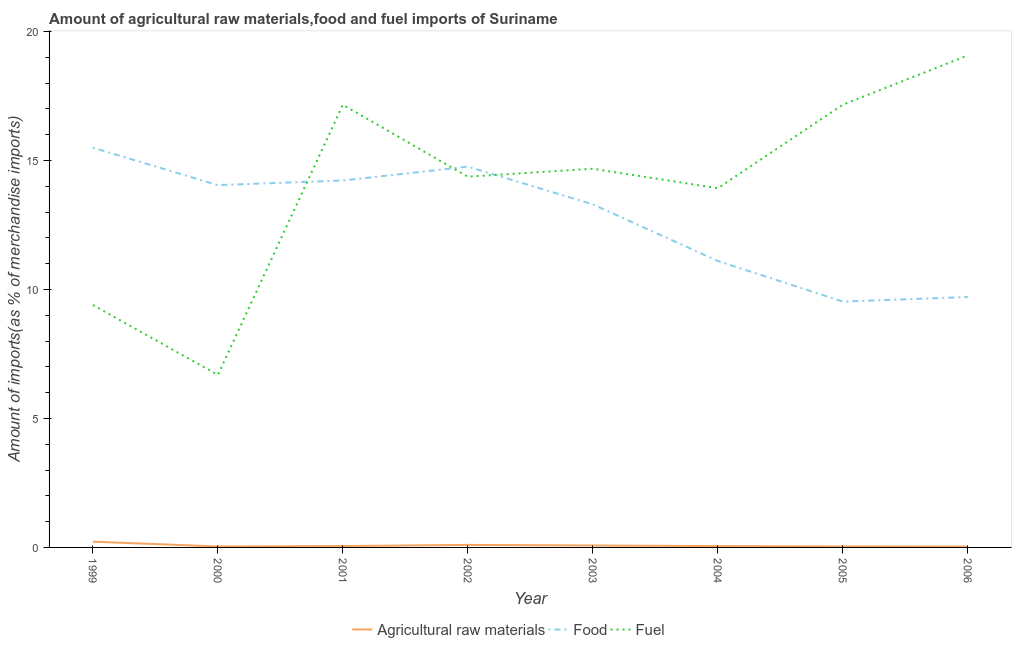Does the line corresponding to percentage of raw materials imports intersect with the line corresponding to percentage of fuel imports?
Make the answer very short. No. What is the percentage of raw materials imports in 2006?
Your answer should be compact. 0.03. Across all years, what is the maximum percentage of raw materials imports?
Provide a short and direct response. 0.22. Across all years, what is the minimum percentage of food imports?
Your response must be concise. 9.53. In which year was the percentage of fuel imports maximum?
Offer a very short reply. 2006. What is the total percentage of raw materials imports in the graph?
Keep it short and to the point. 0.61. What is the difference between the percentage of raw materials imports in 2001 and that in 2002?
Make the answer very short. -0.04. What is the difference between the percentage of food imports in 2006 and the percentage of fuel imports in 2005?
Keep it short and to the point. -7.45. What is the average percentage of fuel imports per year?
Your answer should be very brief. 14.06. In the year 2001, what is the difference between the percentage of raw materials imports and percentage of food imports?
Your answer should be very brief. -14.17. In how many years, is the percentage of raw materials imports greater than 17 %?
Keep it short and to the point. 0. What is the ratio of the percentage of fuel imports in 2002 to that in 2006?
Your answer should be compact. 0.75. Is the percentage of fuel imports in 2000 less than that in 2001?
Give a very brief answer. Yes. Is the difference between the percentage of food imports in 2004 and 2005 greater than the difference between the percentage of raw materials imports in 2004 and 2005?
Your answer should be very brief. Yes. What is the difference between the highest and the second highest percentage of raw materials imports?
Ensure brevity in your answer.  0.13. What is the difference between the highest and the lowest percentage of fuel imports?
Your answer should be compact. 12.39. Is it the case that in every year, the sum of the percentage of raw materials imports and percentage of food imports is greater than the percentage of fuel imports?
Your response must be concise. No. Does the percentage of fuel imports monotonically increase over the years?
Your response must be concise. No. Is the percentage of food imports strictly less than the percentage of fuel imports over the years?
Ensure brevity in your answer.  No. How many lines are there?
Provide a short and direct response. 3. What is the difference between two consecutive major ticks on the Y-axis?
Give a very brief answer. 5. Are the values on the major ticks of Y-axis written in scientific E-notation?
Offer a terse response. No. Does the graph contain grids?
Ensure brevity in your answer.  No. Where does the legend appear in the graph?
Ensure brevity in your answer.  Bottom center. How many legend labels are there?
Ensure brevity in your answer.  3. How are the legend labels stacked?
Your answer should be compact. Horizontal. What is the title of the graph?
Provide a succinct answer. Amount of agricultural raw materials,food and fuel imports of Suriname. Does "Maunufacturing" appear as one of the legend labels in the graph?
Keep it short and to the point. No. What is the label or title of the Y-axis?
Offer a very short reply. Amount of imports(as % of merchandise imports). What is the Amount of imports(as % of merchandise imports) of Agricultural raw materials in 1999?
Your answer should be compact. 0.22. What is the Amount of imports(as % of merchandise imports) in Food in 1999?
Your answer should be very brief. 15.49. What is the Amount of imports(as % of merchandise imports) in Fuel in 1999?
Provide a succinct answer. 9.4. What is the Amount of imports(as % of merchandise imports) of Agricultural raw materials in 2000?
Offer a terse response. 0.04. What is the Amount of imports(as % of merchandise imports) of Food in 2000?
Your answer should be very brief. 14.04. What is the Amount of imports(as % of merchandise imports) in Fuel in 2000?
Ensure brevity in your answer.  6.69. What is the Amount of imports(as % of merchandise imports) of Agricultural raw materials in 2001?
Provide a succinct answer. 0.05. What is the Amount of imports(as % of merchandise imports) of Food in 2001?
Make the answer very short. 14.22. What is the Amount of imports(as % of merchandise imports) of Fuel in 2001?
Provide a short and direct response. 17.16. What is the Amount of imports(as % of merchandise imports) of Agricultural raw materials in 2002?
Your answer should be compact. 0.1. What is the Amount of imports(as % of merchandise imports) in Food in 2002?
Provide a succinct answer. 14.76. What is the Amount of imports(as % of merchandise imports) of Fuel in 2002?
Your answer should be very brief. 14.37. What is the Amount of imports(as % of merchandise imports) of Agricultural raw materials in 2003?
Offer a terse response. 0.08. What is the Amount of imports(as % of merchandise imports) of Food in 2003?
Your answer should be very brief. 13.3. What is the Amount of imports(as % of merchandise imports) in Fuel in 2003?
Offer a terse response. 14.68. What is the Amount of imports(as % of merchandise imports) of Agricultural raw materials in 2004?
Offer a terse response. 0.05. What is the Amount of imports(as % of merchandise imports) in Food in 2004?
Offer a terse response. 11.1. What is the Amount of imports(as % of merchandise imports) of Fuel in 2004?
Your answer should be compact. 13.92. What is the Amount of imports(as % of merchandise imports) of Agricultural raw materials in 2005?
Provide a short and direct response. 0.04. What is the Amount of imports(as % of merchandise imports) in Food in 2005?
Offer a very short reply. 9.53. What is the Amount of imports(as % of merchandise imports) in Fuel in 2005?
Offer a very short reply. 17.16. What is the Amount of imports(as % of merchandise imports) of Agricultural raw materials in 2006?
Keep it short and to the point. 0.03. What is the Amount of imports(as % of merchandise imports) in Food in 2006?
Provide a succinct answer. 9.71. What is the Amount of imports(as % of merchandise imports) of Fuel in 2006?
Your answer should be compact. 19.07. Across all years, what is the maximum Amount of imports(as % of merchandise imports) in Agricultural raw materials?
Make the answer very short. 0.22. Across all years, what is the maximum Amount of imports(as % of merchandise imports) of Food?
Provide a succinct answer. 15.49. Across all years, what is the maximum Amount of imports(as % of merchandise imports) of Fuel?
Your answer should be very brief. 19.07. Across all years, what is the minimum Amount of imports(as % of merchandise imports) in Agricultural raw materials?
Ensure brevity in your answer.  0.03. Across all years, what is the minimum Amount of imports(as % of merchandise imports) of Food?
Provide a succinct answer. 9.53. Across all years, what is the minimum Amount of imports(as % of merchandise imports) of Fuel?
Provide a succinct answer. 6.69. What is the total Amount of imports(as % of merchandise imports) in Agricultural raw materials in the graph?
Provide a succinct answer. 0.61. What is the total Amount of imports(as % of merchandise imports) in Food in the graph?
Make the answer very short. 102.16. What is the total Amount of imports(as % of merchandise imports) in Fuel in the graph?
Give a very brief answer. 112.45. What is the difference between the Amount of imports(as % of merchandise imports) in Agricultural raw materials in 1999 and that in 2000?
Ensure brevity in your answer.  0.19. What is the difference between the Amount of imports(as % of merchandise imports) of Food in 1999 and that in 2000?
Ensure brevity in your answer.  1.45. What is the difference between the Amount of imports(as % of merchandise imports) of Fuel in 1999 and that in 2000?
Ensure brevity in your answer.  2.71. What is the difference between the Amount of imports(as % of merchandise imports) of Agricultural raw materials in 1999 and that in 2001?
Provide a short and direct response. 0.17. What is the difference between the Amount of imports(as % of merchandise imports) in Food in 1999 and that in 2001?
Provide a succinct answer. 1.27. What is the difference between the Amount of imports(as % of merchandise imports) in Fuel in 1999 and that in 2001?
Provide a succinct answer. -7.76. What is the difference between the Amount of imports(as % of merchandise imports) in Agricultural raw materials in 1999 and that in 2002?
Offer a very short reply. 0.13. What is the difference between the Amount of imports(as % of merchandise imports) in Food in 1999 and that in 2002?
Offer a terse response. 0.73. What is the difference between the Amount of imports(as % of merchandise imports) of Fuel in 1999 and that in 2002?
Provide a short and direct response. -4.97. What is the difference between the Amount of imports(as % of merchandise imports) in Agricultural raw materials in 1999 and that in 2003?
Your answer should be compact. 0.15. What is the difference between the Amount of imports(as % of merchandise imports) of Food in 1999 and that in 2003?
Give a very brief answer. 2.2. What is the difference between the Amount of imports(as % of merchandise imports) in Fuel in 1999 and that in 2003?
Your answer should be compact. -5.28. What is the difference between the Amount of imports(as % of merchandise imports) in Agricultural raw materials in 1999 and that in 2004?
Offer a terse response. 0.17. What is the difference between the Amount of imports(as % of merchandise imports) of Food in 1999 and that in 2004?
Your response must be concise. 4.39. What is the difference between the Amount of imports(as % of merchandise imports) of Fuel in 1999 and that in 2004?
Your answer should be compact. -4.53. What is the difference between the Amount of imports(as % of merchandise imports) in Agricultural raw materials in 1999 and that in 2005?
Your response must be concise. 0.18. What is the difference between the Amount of imports(as % of merchandise imports) of Food in 1999 and that in 2005?
Offer a terse response. 5.96. What is the difference between the Amount of imports(as % of merchandise imports) in Fuel in 1999 and that in 2005?
Provide a succinct answer. -7.76. What is the difference between the Amount of imports(as % of merchandise imports) in Agricultural raw materials in 1999 and that in 2006?
Ensure brevity in your answer.  0.19. What is the difference between the Amount of imports(as % of merchandise imports) of Food in 1999 and that in 2006?
Offer a very short reply. 5.79. What is the difference between the Amount of imports(as % of merchandise imports) in Fuel in 1999 and that in 2006?
Your answer should be very brief. -9.68. What is the difference between the Amount of imports(as % of merchandise imports) in Agricultural raw materials in 2000 and that in 2001?
Provide a succinct answer. -0.02. What is the difference between the Amount of imports(as % of merchandise imports) of Food in 2000 and that in 2001?
Provide a succinct answer. -0.18. What is the difference between the Amount of imports(as % of merchandise imports) in Fuel in 2000 and that in 2001?
Your answer should be very brief. -10.47. What is the difference between the Amount of imports(as % of merchandise imports) of Agricultural raw materials in 2000 and that in 2002?
Provide a short and direct response. -0.06. What is the difference between the Amount of imports(as % of merchandise imports) in Food in 2000 and that in 2002?
Your response must be concise. -0.72. What is the difference between the Amount of imports(as % of merchandise imports) of Fuel in 2000 and that in 2002?
Make the answer very short. -7.68. What is the difference between the Amount of imports(as % of merchandise imports) in Agricultural raw materials in 2000 and that in 2003?
Keep it short and to the point. -0.04. What is the difference between the Amount of imports(as % of merchandise imports) of Food in 2000 and that in 2003?
Keep it short and to the point. 0.75. What is the difference between the Amount of imports(as % of merchandise imports) in Fuel in 2000 and that in 2003?
Keep it short and to the point. -7.99. What is the difference between the Amount of imports(as % of merchandise imports) in Agricultural raw materials in 2000 and that in 2004?
Your response must be concise. -0.01. What is the difference between the Amount of imports(as % of merchandise imports) in Food in 2000 and that in 2004?
Make the answer very short. 2.94. What is the difference between the Amount of imports(as % of merchandise imports) of Fuel in 2000 and that in 2004?
Offer a terse response. -7.24. What is the difference between the Amount of imports(as % of merchandise imports) in Agricultural raw materials in 2000 and that in 2005?
Provide a succinct answer. -0. What is the difference between the Amount of imports(as % of merchandise imports) of Food in 2000 and that in 2005?
Offer a terse response. 4.51. What is the difference between the Amount of imports(as % of merchandise imports) of Fuel in 2000 and that in 2005?
Offer a terse response. -10.47. What is the difference between the Amount of imports(as % of merchandise imports) in Agricultural raw materials in 2000 and that in 2006?
Offer a terse response. 0. What is the difference between the Amount of imports(as % of merchandise imports) in Food in 2000 and that in 2006?
Your response must be concise. 4.34. What is the difference between the Amount of imports(as % of merchandise imports) of Fuel in 2000 and that in 2006?
Your answer should be compact. -12.39. What is the difference between the Amount of imports(as % of merchandise imports) of Agricultural raw materials in 2001 and that in 2002?
Offer a very short reply. -0.04. What is the difference between the Amount of imports(as % of merchandise imports) in Food in 2001 and that in 2002?
Ensure brevity in your answer.  -0.54. What is the difference between the Amount of imports(as % of merchandise imports) of Fuel in 2001 and that in 2002?
Provide a succinct answer. 2.79. What is the difference between the Amount of imports(as % of merchandise imports) in Agricultural raw materials in 2001 and that in 2003?
Provide a short and direct response. -0.02. What is the difference between the Amount of imports(as % of merchandise imports) of Food in 2001 and that in 2003?
Keep it short and to the point. 0.93. What is the difference between the Amount of imports(as % of merchandise imports) in Fuel in 2001 and that in 2003?
Provide a succinct answer. 2.48. What is the difference between the Amount of imports(as % of merchandise imports) of Agricultural raw materials in 2001 and that in 2004?
Provide a succinct answer. 0. What is the difference between the Amount of imports(as % of merchandise imports) in Food in 2001 and that in 2004?
Make the answer very short. 3.12. What is the difference between the Amount of imports(as % of merchandise imports) of Fuel in 2001 and that in 2004?
Give a very brief answer. 3.24. What is the difference between the Amount of imports(as % of merchandise imports) of Agricultural raw materials in 2001 and that in 2005?
Your answer should be very brief. 0.01. What is the difference between the Amount of imports(as % of merchandise imports) in Food in 2001 and that in 2005?
Your answer should be very brief. 4.69. What is the difference between the Amount of imports(as % of merchandise imports) of Fuel in 2001 and that in 2005?
Give a very brief answer. -0. What is the difference between the Amount of imports(as % of merchandise imports) in Agricultural raw materials in 2001 and that in 2006?
Your answer should be compact. 0.02. What is the difference between the Amount of imports(as % of merchandise imports) of Food in 2001 and that in 2006?
Offer a terse response. 4.52. What is the difference between the Amount of imports(as % of merchandise imports) in Fuel in 2001 and that in 2006?
Your answer should be very brief. -1.91. What is the difference between the Amount of imports(as % of merchandise imports) of Agricultural raw materials in 2002 and that in 2003?
Make the answer very short. 0.02. What is the difference between the Amount of imports(as % of merchandise imports) of Food in 2002 and that in 2003?
Give a very brief answer. 1.46. What is the difference between the Amount of imports(as % of merchandise imports) of Fuel in 2002 and that in 2003?
Make the answer very short. -0.31. What is the difference between the Amount of imports(as % of merchandise imports) of Agricultural raw materials in 2002 and that in 2004?
Your answer should be compact. 0.05. What is the difference between the Amount of imports(as % of merchandise imports) of Food in 2002 and that in 2004?
Provide a succinct answer. 3.66. What is the difference between the Amount of imports(as % of merchandise imports) of Fuel in 2002 and that in 2004?
Keep it short and to the point. 0.45. What is the difference between the Amount of imports(as % of merchandise imports) of Agricultural raw materials in 2002 and that in 2005?
Provide a succinct answer. 0.06. What is the difference between the Amount of imports(as % of merchandise imports) of Food in 2002 and that in 2005?
Your answer should be very brief. 5.23. What is the difference between the Amount of imports(as % of merchandise imports) in Fuel in 2002 and that in 2005?
Offer a terse response. -2.79. What is the difference between the Amount of imports(as % of merchandise imports) of Agricultural raw materials in 2002 and that in 2006?
Your answer should be very brief. 0.06. What is the difference between the Amount of imports(as % of merchandise imports) in Food in 2002 and that in 2006?
Your response must be concise. 5.05. What is the difference between the Amount of imports(as % of merchandise imports) of Fuel in 2002 and that in 2006?
Keep it short and to the point. -4.7. What is the difference between the Amount of imports(as % of merchandise imports) of Agricultural raw materials in 2003 and that in 2004?
Provide a succinct answer. 0.02. What is the difference between the Amount of imports(as % of merchandise imports) of Food in 2003 and that in 2004?
Your answer should be compact. 2.19. What is the difference between the Amount of imports(as % of merchandise imports) in Fuel in 2003 and that in 2004?
Offer a terse response. 0.76. What is the difference between the Amount of imports(as % of merchandise imports) in Agricultural raw materials in 2003 and that in 2005?
Your response must be concise. 0.04. What is the difference between the Amount of imports(as % of merchandise imports) in Food in 2003 and that in 2005?
Provide a succinct answer. 3.77. What is the difference between the Amount of imports(as % of merchandise imports) in Fuel in 2003 and that in 2005?
Provide a succinct answer. -2.48. What is the difference between the Amount of imports(as % of merchandise imports) in Agricultural raw materials in 2003 and that in 2006?
Your answer should be compact. 0.04. What is the difference between the Amount of imports(as % of merchandise imports) in Food in 2003 and that in 2006?
Offer a terse response. 3.59. What is the difference between the Amount of imports(as % of merchandise imports) in Fuel in 2003 and that in 2006?
Make the answer very short. -4.39. What is the difference between the Amount of imports(as % of merchandise imports) of Agricultural raw materials in 2004 and that in 2005?
Make the answer very short. 0.01. What is the difference between the Amount of imports(as % of merchandise imports) of Food in 2004 and that in 2005?
Make the answer very short. 1.57. What is the difference between the Amount of imports(as % of merchandise imports) in Fuel in 2004 and that in 2005?
Your answer should be very brief. -3.24. What is the difference between the Amount of imports(as % of merchandise imports) in Agricultural raw materials in 2004 and that in 2006?
Ensure brevity in your answer.  0.02. What is the difference between the Amount of imports(as % of merchandise imports) of Food in 2004 and that in 2006?
Your response must be concise. 1.4. What is the difference between the Amount of imports(as % of merchandise imports) of Fuel in 2004 and that in 2006?
Offer a very short reply. -5.15. What is the difference between the Amount of imports(as % of merchandise imports) of Agricultural raw materials in 2005 and that in 2006?
Make the answer very short. 0.01. What is the difference between the Amount of imports(as % of merchandise imports) of Food in 2005 and that in 2006?
Keep it short and to the point. -0.18. What is the difference between the Amount of imports(as % of merchandise imports) in Fuel in 2005 and that in 2006?
Offer a very short reply. -1.91. What is the difference between the Amount of imports(as % of merchandise imports) in Agricultural raw materials in 1999 and the Amount of imports(as % of merchandise imports) in Food in 2000?
Give a very brief answer. -13.82. What is the difference between the Amount of imports(as % of merchandise imports) of Agricultural raw materials in 1999 and the Amount of imports(as % of merchandise imports) of Fuel in 2000?
Provide a short and direct response. -6.46. What is the difference between the Amount of imports(as % of merchandise imports) in Food in 1999 and the Amount of imports(as % of merchandise imports) in Fuel in 2000?
Your answer should be very brief. 8.81. What is the difference between the Amount of imports(as % of merchandise imports) of Agricultural raw materials in 1999 and the Amount of imports(as % of merchandise imports) of Food in 2001?
Provide a succinct answer. -14. What is the difference between the Amount of imports(as % of merchandise imports) in Agricultural raw materials in 1999 and the Amount of imports(as % of merchandise imports) in Fuel in 2001?
Your answer should be very brief. -16.94. What is the difference between the Amount of imports(as % of merchandise imports) in Food in 1999 and the Amount of imports(as % of merchandise imports) in Fuel in 2001?
Ensure brevity in your answer.  -1.67. What is the difference between the Amount of imports(as % of merchandise imports) in Agricultural raw materials in 1999 and the Amount of imports(as % of merchandise imports) in Food in 2002?
Ensure brevity in your answer.  -14.54. What is the difference between the Amount of imports(as % of merchandise imports) of Agricultural raw materials in 1999 and the Amount of imports(as % of merchandise imports) of Fuel in 2002?
Provide a short and direct response. -14.15. What is the difference between the Amount of imports(as % of merchandise imports) of Food in 1999 and the Amount of imports(as % of merchandise imports) of Fuel in 2002?
Offer a terse response. 1.12. What is the difference between the Amount of imports(as % of merchandise imports) of Agricultural raw materials in 1999 and the Amount of imports(as % of merchandise imports) of Food in 2003?
Make the answer very short. -13.08. What is the difference between the Amount of imports(as % of merchandise imports) of Agricultural raw materials in 1999 and the Amount of imports(as % of merchandise imports) of Fuel in 2003?
Make the answer very short. -14.46. What is the difference between the Amount of imports(as % of merchandise imports) in Food in 1999 and the Amount of imports(as % of merchandise imports) in Fuel in 2003?
Keep it short and to the point. 0.81. What is the difference between the Amount of imports(as % of merchandise imports) in Agricultural raw materials in 1999 and the Amount of imports(as % of merchandise imports) in Food in 2004?
Provide a short and direct response. -10.88. What is the difference between the Amount of imports(as % of merchandise imports) in Agricultural raw materials in 1999 and the Amount of imports(as % of merchandise imports) in Fuel in 2004?
Provide a short and direct response. -13.7. What is the difference between the Amount of imports(as % of merchandise imports) of Food in 1999 and the Amount of imports(as % of merchandise imports) of Fuel in 2004?
Offer a very short reply. 1.57. What is the difference between the Amount of imports(as % of merchandise imports) of Agricultural raw materials in 1999 and the Amount of imports(as % of merchandise imports) of Food in 2005?
Give a very brief answer. -9.31. What is the difference between the Amount of imports(as % of merchandise imports) of Agricultural raw materials in 1999 and the Amount of imports(as % of merchandise imports) of Fuel in 2005?
Your answer should be compact. -16.94. What is the difference between the Amount of imports(as % of merchandise imports) of Food in 1999 and the Amount of imports(as % of merchandise imports) of Fuel in 2005?
Your response must be concise. -1.67. What is the difference between the Amount of imports(as % of merchandise imports) of Agricultural raw materials in 1999 and the Amount of imports(as % of merchandise imports) of Food in 2006?
Your answer should be very brief. -9.48. What is the difference between the Amount of imports(as % of merchandise imports) in Agricultural raw materials in 1999 and the Amount of imports(as % of merchandise imports) in Fuel in 2006?
Your response must be concise. -18.85. What is the difference between the Amount of imports(as % of merchandise imports) of Food in 1999 and the Amount of imports(as % of merchandise imports) of Fuel in 2006?
Provide a short and direct response. -3.58. What is the difference between the Amount of imports(as % of merchandise imports) of Agricultural raw materials in 2000 and the Amount of imports(as % of merchandise imports) of Food in 2001?
Ensure brevity in your answer.  -14.19. What is the difference between the Amount of imports(as % of merchandise imports) in Agricultural raw materials in 2000 and the Amount of imports(as % of merchandise imports) in Fuel in 2001?
Make the answer very short. -17.12. What is the difference between the Amount of imports(as % of merchandise imports) of Food in 2000 and the Amount of imports(as % of merchandise imports) of Fuel in 2001?
Your answer should be compact. -3.12. What is the difference between the Amount of imports(as % of merchandise imports) in Agricultural raw materials in 2000 and the Amount of imports(as % of merchandise imports) in Food in 2002?
Your answer should be compact. -14.72. What is the difference between the Amount of imports(as % of merchandise imports) in Agricultural raw materials in 2000 and the Amount of imports(as % of merchandise imports) in Fuel in 2002?
Make the answer very short. -14.33. What is the difference between the Amount of imports(as % of merchandise imports) in Food in 2000 and the Amount of imports(as % of merchandise imports) in Fuel in 2002?
Provide a short and direct response. -0.33. What is the difference between the Amount of imports(as % of merchandise imports) in Agricultural raw materials in 2000 and the Amount of imports(as % of merchandise imports) in Food in 2003?
Offer a very short reply. -13.26. What is the difference between the Amount of imports(as % of merchandise imports) in Agricultural raw materials in 2000 and the Amount of imports(as % of merchandise imports) in Fuel in 2003?
Your response must be concise. -14.64. What is the difference between the Amount of imports(as % of merchandise imports) in Food in 2000 and the Amount of imports(as % of merchandise imports) in Fuel in 2003?
Offer a terse response. -0.64. What is the difference between the Amount of imports(as % of merchandise imports) of Agricultural raw materials in 2000 and the Amount of imports(as % of merchandise imports) of Food in 2004?
Your response must be concise. -11.07. What is the difference between the Amount of imports(as % of merchandise imports) in Agricultural raw materials in 2000 and the Amount of imports(as % of merchandise imports) in Fuel in 2004?
Your response must be concise. -13.89. What is the difference between the Amount of imports(as % of merchandise imports) of Food in 2000 and the Amount of imports(as % of merchandise imports) of Fuel in 2004?
Your response must be concise. 0.12. What is the difference between the Amount of imports(as % of merchandise imports) of Agricultural raw materials in 2000 and the Amount of imports(as % of merchandise imports) of Food in 2005?
Your answer should be very brief. -9.49. What is the difference between the Amount of imports(as % of merchandise imports) of Agricultural raw materials in 2000 and the Amount of imports(as % of merchandise imports) of Fuel in 2005?
Make the answer very short. -17.12. What is the difference between the Amount of imports(as % of merchandise imports) in Food in 2000 and the Amount of imports(as % of merchandise imports) in Fuel in 2005?
Provide a short and direct response. -3.12. What is the difference between the Amount of imports(as % of merchandise imports) of Agricultural raw materials in 2000 and the Amount of imports(as % of merchandise imports) of Food in 2006?
Your answer should be compact. -9.67. What is the difference between the Amount of imports(as % of merchandise imports) of Agricultural raw materials in 2000 and the Amount of imports(as % of merchandise imports) of Fuel in 2006?
Ensure brevity in your answer.  -19.04. What is the difference between the Amount of imports(as % of merchandise imports) of Food in 2000 and the Amount of imports(as % of merchandise imports) of Fuel in 2006?
Provide a short and direct response. -5.03. What is the difference between the Amount of imports(as % of merchandise imports) of Agricultural raw materials in 2001 and the Amount of imports(as % of merchandise imports) of Food in 2002?
Ensure brevity in your answer.  -14.71. What is the difference between the Amount of imports(as % of merchandise imports) in Agricultural raw materials in 2001 and the Amount of imports(as % of merchandise imports) in Fuel in 2002?
Keep it short and to the point. -14.32. What is the difference between the Amount of imports(as % of merchandise imports) in Food in 2001 and the Amount of imports(as % of merchandise imports) in Fuel in 2002?
Offer a terse response. -0.15. What is the difference between the Amount of imports(as % of merchandise imports) of Agricultural raw materials in 2001 and the Amount of imports(as % of merchandise imports) of Food in 2003?
Provide a short and direct response. -13.24. What is the difference between the Amount of imports(as % of merchandise imports) in Agricultural raw materials in 2001 and the Amount of imports(as % of merchandise imports) in Fuel in 2003?
Provide a short and direct response. -14.63. What is the difference between the Amount of imports(as % of merchandise imports) in Food in 2001 and the Amount of imports(as % of merchandise imports) in Fuel in 2003?
Provide a succinct answer. -0.46. What is the difference between the Amount of imports(as % of merchandise imports) of Agricultural raw materials in 2001 and the Amount of imports(as % of merchandise imports) of Food in 2004?
Give a very brief answer. -11.05. What is the difference between the Amount of imports(as % of merchandise imports) of Agricultural raw materials in 2001 and the Amount of imports(as % of merchandise imports) of Fuel in 2004?
Your response must be concise. -13.87. What is the difference between the Amount of imports(as % of merchandise imports) in Food in 2001 and the Amount of imports(as % of merchandise imports) in Fuel in 2004?
Your answer should be compact. 0.3. What is the difference between the Amount of imports(as % of merchandise imports) of Agricultural raw materials in 2001 and the Amount of imports(as % of merchandise imports) of Food in 2005?
Offer a very short reply. -9.48. What is the difference between the Amount of imports(as % of merchandise imports) in Agricultural raw materials in 2001 and the Amount of imports(as % of merchandise imports) in Fuel in 2005?
Your answer should be compact. -17.11. What is the difference between the Amount of imports(as % of merchandise imports) in Food in 2001 and the Amount of imports(as % of merchandise imports) in Fuel in 2005?
Your answer should be compact. -2.94. What is the difference between the Amount of imports(as % of merchandise imports) in Agricultural raw materials in 2001 and the Amount of imports(as % of merchandise imports) in Food in 2006?
Provide a short and direct response. -9.65. What is the difference between the Amount of imports(as % of merchandise imports) in Agricultural raw materials in 2001 and the Amount of imports(as % of merchandise imports) in Fuel in 2006?
Your response must be concise. -19.02. What is the difference between the Amount of imports(as % of merchandise imports) in Food in 2001 and the Amount of imports(as % of merchandise imports) in Fuel in 2006?
Ensure brevity in your answer.  -4.85. What is the difference between the Amount of imports(as % of merchandise imports) of Agricultural raw materials in 2002 and the Amount of imports(as % of merchandise imports) of Food in 2003?
Give a very brief answer. -13.2. What is the difference between the Amount of imports(as % of merchandise imports) of Agricultural raw materials in 2002 and the Amount of imports(as % of merchandise imports) of Fuel in 2003?
Keep it short and to the point. -14.58. What is the difference between the Amount of imports(as % of merchandise imports) in Food in 2002 and the Amount of imports(as % of merchandise imports) in Fuel in 2003?
Ensure brevity in your answer.  0.08. What is the difference between the Amount of imports(as % of merchandise imports) in Agricultural raw materials in 2002 and the Amount of imports(as % of merchandise imports) in Food in 2004?
Offer a very short reply. -11.01. What is the difference between the Amount of imports(as % of merchandise imports) of Agricultural raw materials in 2002 and the Amount of imports(as % of merchandise imports) of Fuel in 2004?
Offer a very short reply. -13.83. What is the difference between the Amount of imports(as % of merchandise imports) in Food in 2002 and the Amount of imports(as % of merchandise imports) in Fuel in 2004?
Make the answer very short. 0.84. What is the difference between the Amount of imports(as % of merchandise imports) in Agricultural raw materials in 2002 and the Amount of imports(as % of merchandise imports) in Food in 2005?
Offer a very short reply. -9.43. What is the difference between the Amount of imports(as % of merchandise imports) of Agricultural raw materials in 2002 and the Amount of imports(as % of merchandise imports) of Fuel in 2005?
Ensure brevity in your answer.  -17.06. What is the difference between the Amount of imports(as % of merchandise imports) in Food in 2002 and the Amount of imports(as % of merchandise imports) in Fuel in 2005?
Make the answer very short. -2.4. What is the difference between the Amount of imports(as % of merchandise imports) of Agricultural raw materials in 2002 and the Amount of imports(as % of merchandise imports) of Food in 2006?
Make the answer very short. -9.61. What is the difference between the Amount of imports(as % of merchandise imports) of Agricultural raw materials in 2002 and the Amount of imports(as % of merchandise imports) of Fuel in 2006?
Offer a very short reply. -18.98. What is the difference between the Amount of imports(as % of merchandise imports) of Food in 2002 and the Amount of imports(as % of merchandise imports) of Fuel in 2006?
Offer a very short reply. -4.31. What is the difference between the Amount of imports(as % of merchandise imports) of Agricultural raw materials in 2003 and the Amount of imports(as % of merchandise imports) of Food in 2004?
Make the answer very short. -11.03. What is the difference between the Amount of imports(as % of merchandise imports) in Agricultural raw materials in 2003 and the Amount of imports(as % of merchandise imports) in Fuel in 2004?
Your answer should be compact. -13.85. What is the difference between the Amount of imports(as % of merchandise imports) of Food in 2003 and the Amount of imports(as % of merchandise imports) of Fuel in 2004?
Give a very brief answer. -0.63. What is the difference between the Amount of imports(as % of merchandise imports) in Agricultural raw materials in 2003 and the Amount of imports(as % of merchandise imports) in Food in 2005?
Ensure brevity in your answer.  -9.45. What is the difference between the Amount of imports(as % of merchandise imports) of Agricultural raw materials in 2003 and the Amount of imports(as % of merchandise imports) of Fuel in 2005?
Keep it short and to the point. -17.09. What is the difference between the Amount of imports(as % of merchandise imports) in Food in 2003 and the Amount of imports(as % of merchandise imports) in Fuel in 2005?
Provide a succinct answer. -3.86. What is the difference between the Amount of imports(as % of merchandise imports) of Agricultural raw materials in 2003 and the Amount of imports(as % of merchandise imports) of Food in 2006?
Offer a terse response. -9.63. What is the difference between the Amount of imports(as % of merchandise imports) of Agricultural raw materials in 2003 and the Amount of imports(as % of merchandise imports) of Fuel in 2006?
Provide a short and direct response. -19. What is the difference between the Amount of imports(as % of merchandise imports) in Food in 2003 and the Amount of imports(as % of merchandise imports) in Fuel in 2006?
Provide a succinct answer. -5.78. What is the difference between the Amount of imports(as % of merchandise imports) in Agricultural raw materials in 2004 and the Amount of imports(as % of merchandise imports) in Food in 2005?
Offer a terse response. -9.48. What is the difference between the Amount of imports(as % of merchandise imports) of Agricultural raw materials in 2004 and the Amount of imports(as % of merchandise imports) of Fuel in 2005?
Give a very brief answer. -17.11. What is the difference between the Amount of imports(as % of merchandise imports) in Food in 2004 and the Amount of imports(as % of merchandise imports) in Fuel in 2005?
Your answer should be very brief. -6.06. What is the difference between the Amount of imports(as % of merchandise imports) in Agricultural raw materials in 2004 and the Amount of imports(as % of merchandise imports) in Food in 2006?
Offer a very short reply. -9.66. What is the difference between the Amount of imports(as % of merchandise imports) in Agricultural raw materials in 2004 and the Amount of imports(as % of merchandise imports) in Fuel in 2006?
Provide a succinct answer. -19.02. What is the difference between the Amount of imports(as % of merchandise imports) in Food in 2004 and the Amount of imports(as % of merchandise imports) in Fuel in 2006?
Offer a terse response. -7.97. What is the difference between the Amount of imports(as % of merchandise imports) of Agricultural raw materials in 2005 and the Amount of imports(as % of merchandise imports) of Food in 2006?
Your answer should be compact. -9.67. What is the difference between the Amount of imports(as % of merchandise imports) of Agricultural raw materials in 2005 and the Amount of imports(as % of merchandise imports) of Fuel in 2006?
Ensure brevity in your answer.  -19.03. What is the difference between the Amount of imports(as % of merchandise imports) in Food in 2005 and the Amount of imports(as % of merchandise imports) in Fuel in 2006?
Your response must be concise. -9.54. What is the average Amount of imports(as % of merchandise imports) in Agricultural raw materials per year?
Provide a succinct answer. 0.08. What is the average Amount of imports(as % of merchandise imports) in Food per year?
Your response must be concise. 12.77. What is the average Amount of imports(as % of merchandise imports) in Fuel per year?
Provide a succinct answer. 14.06. In the year 1999, what is the difference between the Amount of imports(as % of merchandise imports) of Agricultural raw materials and Amount of imports(as % of merchandise imports) of Food?
Your response must be concise. -15.27. In the year 1999, what is the difference between the Amount of imports(as % of merchandise imports) of Agricultural raw materials and Amount of imports(as % of merchandise imports) of Fuel?
Make the answer very short. -9.17. In the year 1999, what is the difference between the Amount of imports(as % of merchandise imports) of Food and Amount of imports(as % of merchandise imports) of Fuel?
Ensure brevity in your answer.  6.1. In the year 2000, what is the difference between the Amount of imports(as % of merchandise imports) of Agricultural raw materials and Amount of imports(as % of merchandise imports) of Food?
Offer a terse response. -14.01. In the year 2000, what is the difference between the Amount of imports(as % of merchandise imports) in Agricultural raw materials and Amount of imports(as % of merchandise imports) in Fuel?
Keep it short and to the point. -6.65. In the year 2000, what is the difference between the Amount of imports(as % of merchandise imports) of Food and Amount of imports(as % of merchandise imports) of Fuel?
Your answer should be compact. 7.36. In the year 2001, what is the difference between the Amount of imports(as % of merchandise imports) in Agricultural raw materials and Amount of imports(as % of merchandise imports) in Food?
Your response must be concise. -14.17. In the year 2001, what is the difference between the Amount of imports(as % of merchandise imports) in Agricultural raw materials and Amount of imports(as % of merchandise imports) in Fuel?
Offer a very short reply. -17.11. In the year 2001, what is the difference between the Amount of imports(as % of merchandise imports) of Food and Amount of imports(as % of merchandise imports) of Fuel?
Offer a terse response. -2.94. In the year 2002, what is the difference between the Amount of imports(as % of merchandise imports) of Agricultural raw materials and Amount of imports(as % of merchandise imports) of Food?
Your answer should be very brief. -14.66. In the year 2002, what is the difference between the Amount of imports(as % of merchandise imports) of Agricultural raw materials and Amount of imports(as % of merchandise imports) of Fuel?
Provide a short and direct response. -14.27. In the year 2002, what is the difference between the Amount of imports(as % of merchandise imports) of Food and Amount of imports(as % of merchandise imports) of Fuel?
Make the answer very short. 0.39. In the year 2003, what is the difference between the Amount of imports(as % of merchandise imports) in Agricultural raw materials and Amount of imports(as % of merchandise imports) in Food?
Offer a terse response. -13.22. In the year 2003, what is the difference between the Amount of imports(as % of merchandise imports) in Agricultural raw materials and Amount of imports(as % of merchandise imports) in Fuel?
Make the answer very short. -14.6. In the year 2003, what is the difference between the Amount of imports(as % of merchandise imports) of Food and Amount of imports(as % of merchandise imports) of Fuel?
Provide a succinct answer. -1.38. In the year 2004, what is the difference between the Amount of imports(as % of merchandise imports) of Agricultural raw materials and Amount of imports(as % of merchandise imports) of Food?
Your answer should be very brief. -11.05. In the year 2004, what is the difference between the Amount of imports(as % of merchandise imports) in Agricultural raw materials and Amount of imports(as % of merchandise imports) in Fuel?
Make the answer very short. -13.87. In the year 2004, what is the difference between the Amount of imports(as % of merchandise imports) of Food and Amount of imports(as % of merchandise imports) of Fuel?
Offer a terse response. -2.82. In the year 2005, what is the difference between the Amount of imports(as % of merchandise imports) of Agricultural raw materials and Amount of imports(as % of merchandise imports) of Food?
Give a very brief answer. -9.49. In the year 2005, what is the difference between the Amount of imports(as % of merchandise imports) of Agricultural raw materials and Amount of imports(as % of merchandise imports) of Fuel?
Your answer should be compact. -17.12. In the year 2005, what is the difference between the Amount of imports(as % of merchandise imports) of Food and Amount of imports(as % of merchandise imports) of Fuel?
Your answer should be very brief. -7.63. In the year 2006, what is the difference between the Amount of imports(as % of merchandise imports) in Agricultural raw materials and Amount of imports(as % of merchandise imports) in Food?
Provide a succinct answer. -9.67. In the year 2006, what is the difference between the Amount of imports(as % of merchandise imports) of Agricultural raw materials and Amount of imports(as % of merchandise imports) of Fuel?
Offer a terse response. -19.04. In the year 2006, what is the difference between the Amount of imports(as % of merchandise imports) of Food and Amount of imports(as % of merchandise imports) of Fuel?
Make the answer very short. -9.37. What is the ratio of the Amount of imports(as % of merchandise imports) of Agricultural raw materials in 1999 to that in 2000?
Your response must be concise. 6.02. What is the ratio of the Amount of imports(as % of merchandise imports) of Food in 1999 to that in 2000?
Your response must be concise. 1.1. What is the ratio of the Amount of imports(as % of merchandise imports) in Fuel in 1999 to that in 2000?
Ensure brevity in your answer.  1.41. What is the ratio of the Amount of imports(as % of merchandise imports) in Agricultural raw materials in 1999 to that in 2001?
Your answer should be compact. 4.15. What is the ratio of the Amount of imports(as % of merchandise imports) in Food in 1999 to that in 2001?
Offer a very short reply. 1.09. What is the ratio of the Amount of imports(as % of merchandise imports) of Fuel in 1999 to that in 2001?
Your answer should be compact. 0.55. What is the ratio of the Amount of imports(as % of merchandise imports) of Agricultural raw materials in 1999 to that in 2002?
Ensure brevity in your answer.  2.28. What is the ratio of the Amount of imports(as % of merchandise imports) of Food in 1999 to that in 2002?
Provide a succinct answer. 1.05. What is the ratio of the Amount of imports(as % of merchandise imports) in Fuel in 1999 to that in 2002?
Offer a terse response. 0.65. What is the ratio of the Amount of imports(as % of merchandise imports) in Agricultural raw materials in 1999 to that in 2003?
Give a very brief answer. 2.95. What is the ratio of the Amount of imports(as % of merchandise imports) of Food in 1999 to that in 2003?
Offer a terse response. 1.17. What is the ratio of the Amount of imports(as % of merchandise imports) of Fuel in 1999 to that in 2003?
Offer a very short reply. 0.64. What is the ratio of the Amount of imports(as % of merchandise imports) of Agricultural raw materials in 1999 to that in 2004?
Provide a succinct answer. 4.37. What is the ratio of the Amount of imports(as % of merchandise imports) of Food in 1999 to that in 2004?
Offer a very short reply. 1.4. What is the ratio of the Amount of imports(as % of merchandise imports) in Fuel in 1999 to that in 2004?
Provide a short and direct response. 0.67. What is the ratio of the Amount of imports(as % of merchandise imports) of Agricultural raw materials in 1999 to that in 2005?
Your response must be concise. 5.62. What is the ratio of the Amount of imports(as % of merchandise imports) in Food in 1999 to that in 2005?
Offer a very short reply. 1.63. What is the ratio of the Amount of imports(as % of merchandise imports) in Fuel in 1999 to that in 2005?
Offer a very short reply. 0.55. What is the ratio of the Amount of imports(as % of merchandise imports) in Agricultural raw materials in 1999 to that in 2006?
Give a very brief answer. 6.64. What is the ratio of the Amount of imports(as % of merchandise imports) of Food in 1999 to that in 2006?
Your answer should be very brief. 1.6. What is the ratio of the Amount of imports(as % of merchandise imports) of Fuel in 1999 to that in 2006?
Offer a terse response. 0.49. What is the ratio of the Amount of imports(as % of merchandise imports) in Agricultural raw materials in 2000 to that in 2001?
Make the answer very short. 0.69. What is the ratio of the Amount of imports(as % of merchandise imports) of Food in 2000 to that in 2001?
Provide a succinct answer. 0.99. What is the ratio of the Amount of imports(as % of merchandise imports) of Fuel in 2000 to that in 2001?
Provide a succinct answer. 0.39. What is the ratio of the Amount of imports(as % of merchandise imports) in Agricultural raw materials in 2000 to that in 2002?
Your answer should be very brief. 0.38. What is the ratio of the Amount of imports(as % of merchandise imports) of Food in 2000 to that in 2002?
Make the answer very short. 0.95. What is the ratio of the Amount of imports(as % of merchandise imports) in Fuel in 2000 to that in 2002?
Your answer should be compact. 0.47. What is the ratio of the Amount of imports(as % of merchandise imports) in Agricultural raw materials in 2000 to that in 2003?
Make the answer very short. 0.49. What is the ratio of the Amount of imports(as % of merchandise imports) of Food in 2000 to that in 2003?
Make the answer very short. 1.06. What is the ratio of the Amount of imports(as % of merchandise imports) in Fuel in 2000 to that in 2003?
Your answer should be very brief. 0.46. What is the ratio of the Amount of imports(as % of merchandise imports) of Agricultural raw materials in 2000 to that in 2004?
Your answer should be compact. 0.73. What is the ratio of the Amount of imports(as % of merchandise imports) in Food in 2000 to that in 2004?
Make the answer very short. 1.26. What is the ratio of the Amount of imports(as % of merchandise imports) in Fuel in 2000 to that in 2004?
Your answer should be very brief. 0.48. What is the ratio of the Amount of imports(as % of merchandise imports) of Agricultural raw materials in 2000 to that in 2005?
Provide a succinct answer. 0.93. What is the ratio of the Amount of imports(as % of merchandise imports) in Food in 2000 to that in 2005?
Offer a very short reply. 1.47. What is the ratio of the Amount of imports(as % of merchandise imports) in Fuel in 2000 to that in 2005?
Make the answer very short. 0.39. What is the ratio of the Amount of imports(as % of merchandise imports) of Agricultural raw materials in 2000 to that in 2006?
Offer a very short reply. 1.1. What is the ratio of the Amount of imports(as % of merchandise imports) of Food in 2000 to that in 2006?
Offer a terse response. 1.45. What is the ratio of the Amount of imports(as % of merchandise imports) in Fuel in 2000 to that in 2006?
Offer a very short reply. 0.35. What is the ratio of the Amount of imports(as % of merchandise imports) of Agricultural raw materials in 2001 to that in 2002?
Make the answer very short. 0.55. What is the ratio of the Amount of imports(as % of merchandise imports) in Food in 2001 to that in 2002?
Provide a short and direct response. 0.96. What is the ratio of the Amount of imports(as % of merchandise imports) in Fuel in 2001 to that in 2002?
Provide a short and direct response. 1.19. What is the ratio of the Amount of imports(as % of merchandise imports) in Agricultural raw materials in 2001 to that in 2003?
Your response must be concise. 0.71. What is the ratio of the Amount of imports(as % of merchandise imports) in Food in 2001 to that in 2003?
Your answer should be very brief. 1.07. What is the ratio of the Amount of imports(as % of merchandise imports) of Fuel in 2001 to that in 2003?
Provide a short and direct response. 1.17. What is the ratio of the Amount of imports(as % of merchandise imports) in Agricultural raw materials in 2001 to that in 2004?
Provide a succinct answer. 1.05. What is the ratio of the Amount of imports(as % of merchandise imports) in Food in 2001 to that in 2004?
Your response must be concise. 1.28. What is the ratio of the Amount of imports(as % of merchandise imports) of Fuel in 2001 to that in 2004?
Your answer should be compact. 1.23. What is the ratio of the Amount of imports(as % of merchandise imports) in Agricultural raw materials in 2001 to that in 2005?
Offer a terse response. 1.35. What is the ratio of the Amount of imports(as % of merchandise imports) of Food in 2001 to that in 2005?
Keep it short and to the point. 1.49. What is the ratio of the Amount of imports(as % of merchandise imports) of Agricultural raw materials in 2001 to that in 2006?
Provide a succinct answer. 1.6. What is the ratio of the Amount of imports(as % of merchandise imports) of Food in 2001 to that in 2006?
Provide a short and direct response. 1.47. What is the ratio of the Amount of imports(as % of merchandise imports) of Fuel in 2001 to that in 2006?
Offer a terse response. 0.9. What is the ratio of the Amount of imports(as % of merchandise imports) in Agricultural raw materials in 2002 to that in 2003?
Your response must be concise. 1.29. What is the ratio of the Amount of imports(as % of merchandise imports) of Food in 2002 to that in 2003?
Your response must be concise. 1.11. What is the ratio of the Amount of imports(as % of merchandise imports) in Fuel in 2002 to that in 2003?
Offer a terse response. 0.98. What is the ratio of the Amount of imports(as % of merchandise imports) in Agricultural raw materials in 2002 to that in 2004?
Give a very brief answer. 1.92. What is the ratio of the Amount of imports(as % of merchandise imports) in Food in 2002 to that in 2004?
Your answer should be compact. 1.33. What is the ratio of the Amount of imports(as % of merchandise imports) in Fuel in 2002 to that in 2004?
Your response must be concise. 1.03. What is the ratio of the Amount of imports(as % of merchandise imports) in Agricultural raw materials in 2002 to that in 2005?
Ensure brevity in your answer.  2.46. What is the ratio of the Amount of imports(as % of merchandise imports) in Food in 2002 to that in 2005?
Provide a succinct answer. 1.55. What is the ratio of the Amount of imports(as % of merchandise imports) in Fuel in 2002 to that in 2005?
Offer a very short reply. 0.84. What is the ratio of the Amount of imports(as % of merchandise imports) of Agricultural raw materials in 2002 to that in 2006?
Give a very brief answer. 2.91. What is the ratio of the Amount of imports(as % of merchandise imports) of Food in 2002 to that in 2006?
Make the answer very short. 1.52. What is the ratio of the Amount of imports(as % of merchandise imports) of Fuel in 2002 to that in 2006?
Provide a short and direct response. 0.75. What is the ratio of the Amount of imports(as % of merchandise imports) in Agricultural raw materials in 2003 to that in 2004?
Your response must be concise. 1.48. What is the ratio of the Amount of imports(as % of merchandise imports) of Food in 2003 to that in 2004?
Offer a very short reply. 1.2. What is the ratio of the Amount of imports(as % of merchandise imports) in Fuel in 2003 to that in 2004?
Your answer should be very brief. 1.05. What is the ratio of the Amount of imports(as % of merchandise imports) in Agricultural raw materials in 2003 to that in 2005?
Keep it short and to the point. 1.9. What is the ratio of the Amount of imports(as % of merchandise imports) in Food in 2003 to that in 2005?
Make the answer very short. 1.4. What is the ratio of the Amount of imports(as % of merchandise imports) of Fuel in 2003 to that in 2005?
Give a very brief answer. 0.86. What is the ratio of the Amount of imports(as % of merchandise imports) in Agricultural raw materials in 2003 to that in 2006?
Your response must be concise. 2.25. What is the ratio of the Amount of imports(as % of merchandise imports) of Food in 2003 to that in 2006?
Keep it short and to the point. 1.37. What is the ratio of the Amount of imports(as % of merchandise imports) of Fuel in 2003 to that in 2006?
Keep it short and to the point. 0.77. What is the ratio of the Amount of imports(as % of merchandise imports) in Agricultural raw materials in 2004 to that in 2005?
Ensure brevity in your answer.  1.29. What is the ratio of the Amount of imports(as % of merchandise imports) of Food in 2004 to that in 2005?
Provide a succinct answer. 1.17. What is the ratio of the Amount of imports(as % of merchandise imports) in Fuel in 2004 to that in 2005?
Give a very brief answer. 0.81. What is the ratio of the Amount of imports(as % of merchandise imports) in Agricultural raw materials in 2004 to that in 2006?
Offer a very short reply. 1.52. What is the ratio of the Amount of imports(as % of merchandise imports) of Food in 2004 to that in 2006?
Provide a short and direct response. 1.14. What is the ratio of the Amount of imports(as % of merchandise imports) of Fuel in 2004 to that in 2006?
Keep it short and to the point. 0.73. What is the ratio of the Amount of imports(as % of merchandise imports) of Agricultural raw materials in 2005 to that in 2006?
Your answer should be very brief. 1.18. What is the ratio of the Amount of imports(as % of merchandise imports) in Food in 2005 to that in 2006?
Give a very brief answer. 0.98. What is the ratio of the Amount of imports(as % of merchandise imports) in Fuel in 2005 to that in 2006?
Make the answer very short. 0.9. What is the difference between the highest and the second highest Amount of imports(as % of merchandise imports) in Agricultural raw materials?
Keep it short and to the point. 0.13. What is the difference between the highest and the second highest Amount of imports(as % of merchandise imports) in Food?
Your answer should be compact. 0.73. What is the difference between the highest and the second highest Amount of imports(as % of merchandise imports) in Fuel?
Offer a terse response. 1.91. What is the difference between the highest and the lowest Amount of imports(as % of merchandise imports) of Agricultural raw materials?
Make the answer very short. 0.19. What is the difference between the highest and the lowest Amount of imports(as % of merchandise imports) in Food?
Ensure brevity in your answer.  5.96. What is the difference between the highest and the lowest Amount of imports(as % of merchandise imports) of Fuel?
Keep it short and to the point. 12.39. 